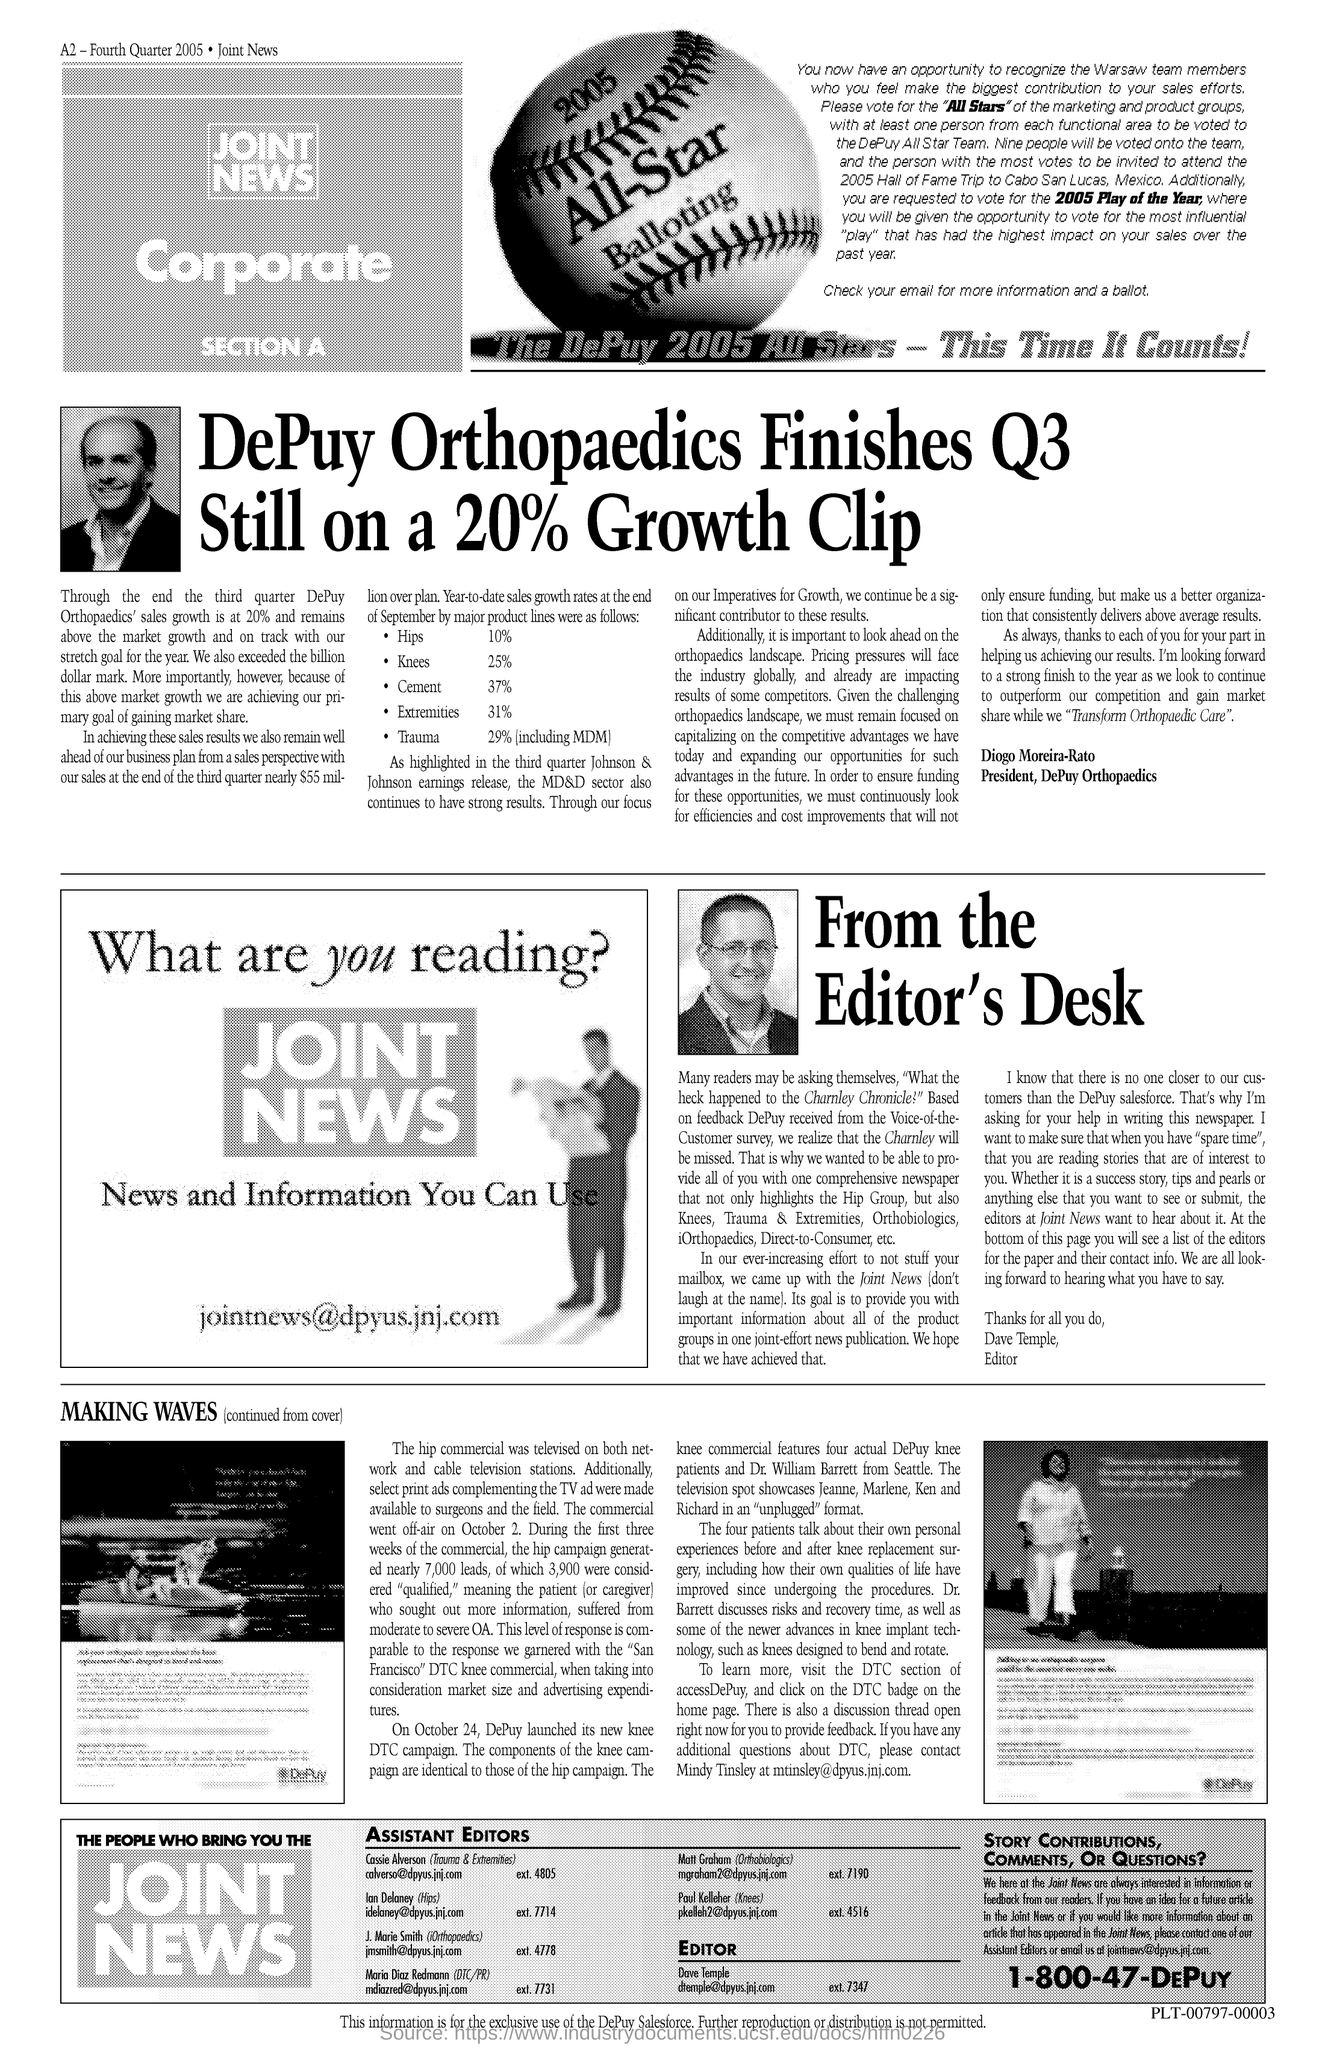Outline some significant characteristics in this image. Diogo Moreira-Rato is the president of DePuy Orthopaedics. 